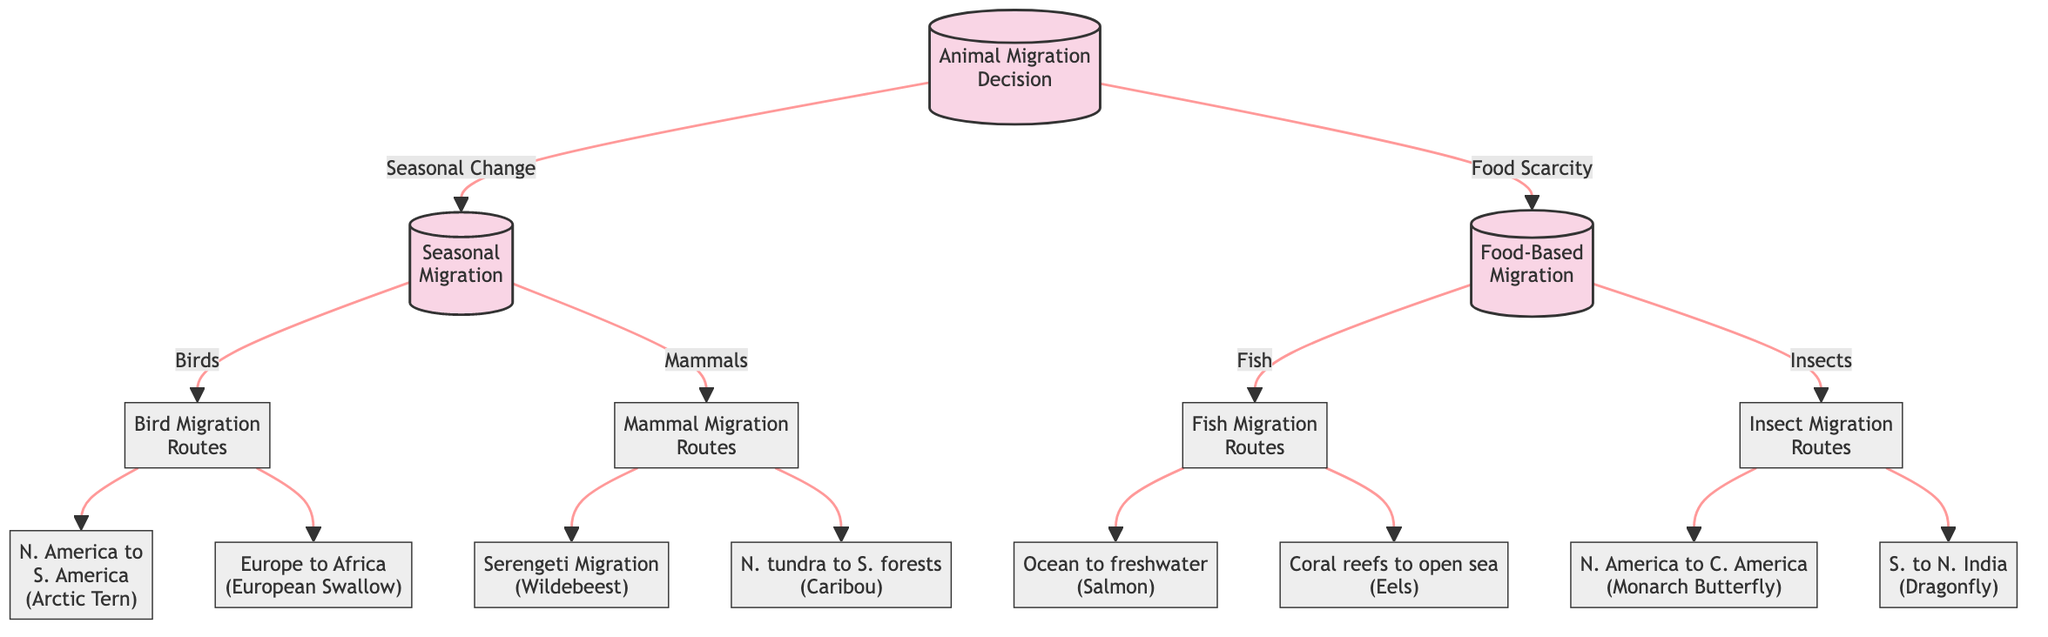What is the starting point of the decision tree? The starting point of the decision tree is the "Animal Migration Decision" node, which determines if migration is necessary based on seasonal changes or food scarcity.
Answer: Animal Migration Decision How many decision nodes are in the diagram? The diagram contains three decision nodes: "Animal Migration Decision," "Seasonal Migration," and "Food-Based Migration."
Answer: 3 What animal type is associated with the route from North America to South America? The route from North America to South America is associated with the Arctic Tern, which is a species of bird.
Answer: Arctic Tern Which route do fish generally migrate to? Fish generally migrate from the ocean to freshwater streams, exemplified by the Salmon.
Answer: Ocean to freshwater streams What are the two conditions leading to migration in the first decision node? The two conditions leading to migration in the first decision node are "Seasonal Change" and "Food Scarcity."
Answer: Seasonal Change, Food Scarcity Which species is associated with the migration from the Serengeti? The species associated with the migration from the Serengeti is the Wildebeest.
Answer: Wildebeest What type of migration routes do mammals follow according to the diagram? According to the diagram, mammals follow typical migration routes which include the Serengeti Migration and Northern tundra to southern forests.
Answer: Mammal Migration Routes How many routes are shown for insect migration? The diagram indicates two routes for insect migration: North America to Central America and South to North India.
Answer: 2 What is the common factor for the routes of the birds in this decision tree? The common factor for the routes of the birds is that they all involve long-distance migration to follow favorable climates, such as the Arctic Tern migrating from North America to South America.
Answer: Long-distance migration 